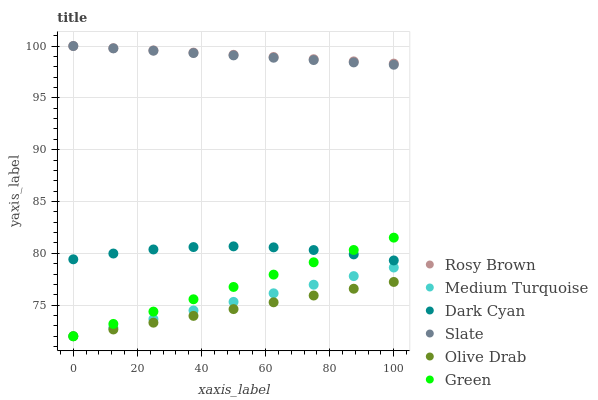Does Olive Drab have the minimum area under the curve?
Answer yes or no. Yes. Does Rosy Brown have the maximum area under the curve?
Answer yes or no. Yes. Does Green have the minimum area under the curve?
Answer yes or no. No. Does Green have the maximum area under the curve?
Answer yes or no. No. Is Green the smoothest?
Answer yes or no. Yes. Is Dark Cyan the roughest?
Answer yes or no. Yes. Is Rosy Brown the smoothest?
Answer yes or no. No. Is Rosy Brown the roughest?
Answer yes or no. No. Does Green have the lowest value?
Answer yes or no. Yes. Does Rosy Brown have the lowest value?
Answer yes or no. No. Does Rosy Brown have the highest value?
Answer yes or no. Yes. Does Green have the highest value?
Answer yes or no. No. Is Dark Cyan less than Slate?
Answer yes or no. Yes. Is Slate greater than Dark Cyan?
Answer yes or no. Yes. Does Green intersect Dark Cyan?
Answer yes or no. Yes. Is Green less than Dark Cyan?
Answer yes or no. No. Is Green greater than Dark Cyan?
Answer yes or no. No. Does Dark Cyan intersect Slate?
Answer yes or no. No. 